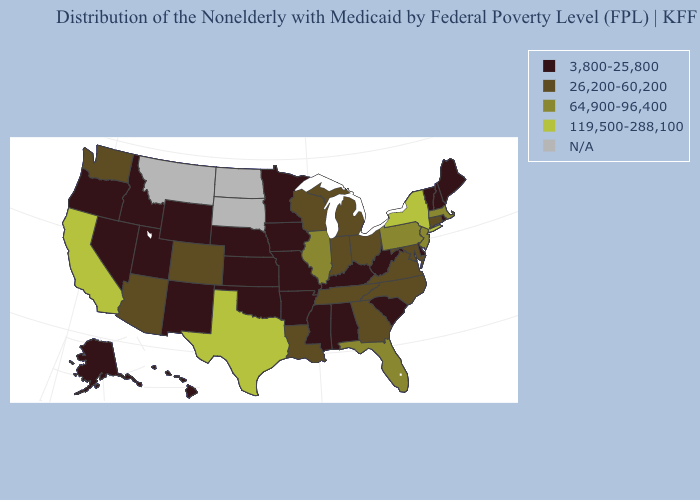Name the states that have a value in the range N/A?
Quick response, please. Montana, North Dakota, South Dakota. What is the value of Idaho?
Give a very brief answer. 3,800-25,800. What is the highest value in the MidWest ?
Answer briefly. 64,900-96,400. What is the highest value in the USA?
Write a very short answer. 119,500-288,100. Does the first symbol in the legend represent the smallest category?
Quick response, please. Yes. Does California have the lowest value in the USA?
Answer briefly. No. Which states have the highest value in the USA?
Short answer required. California, New York, Texas. What is the value of Oregon?
Write a very short answer. 3,800-25,800. What is the lowest value in states that border New Hampshire?
Concise answer only. 3,800-25,800. Does Connecticut have the lowest value in the Northeast?
Write a very short answer. No. Name the states that have a value in the range 64,900-96,400?
Answer briefly. Florida, Illinois, Massachusetts, New Jersey, Pennsylvania. What is the value of Kentucky?
Short answer required. 3,800-25,800. 